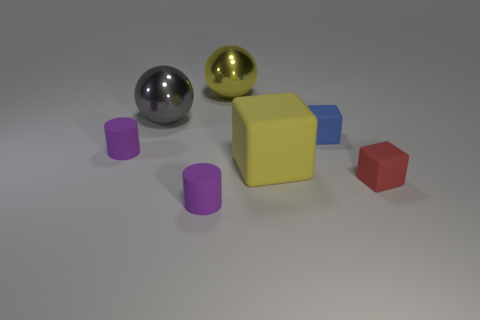Subtract all tiny red blocks. How many blocks are left? 2 Add 1 blue matte cubes. How many objects exist? 8 Subtract all balls. How many objects are left? 5 Subtract all gray cubes. Subtract all green cylinders. How many cubes are left? 3 Subtract all small blue matte spheres. Subtract all small rubber things. How many objects are left? 3 Add 5 red rubber things. How many red rubber things are left? 6 Add 4 tiny cylinders. How many tiny cylinders exist? 6 Subtract 0 blue cylinders. How many objects are left? 7 